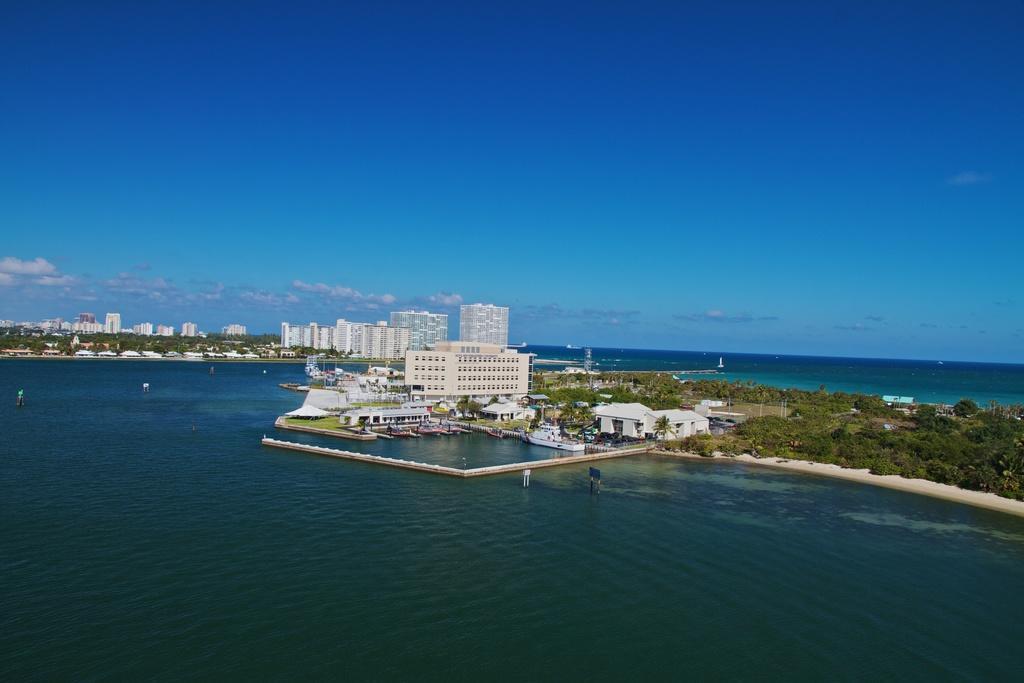Can you describe this image briefly? In this image we can see buildings, trees, water, boats sky and clouds. 